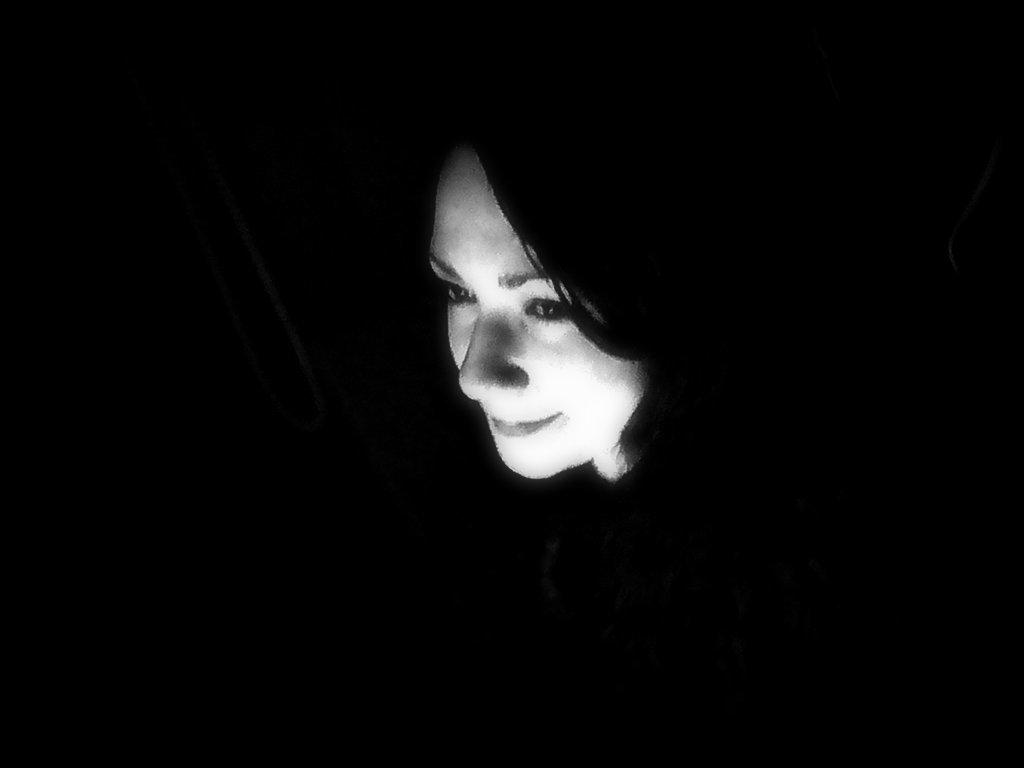What is the main subject of the image? There is a person's face in the image. What color is the background of the image? The background of the image is black. What direction is the boot facing in the image? There is no boot present in the image, so it is not possible to determine the direction it might be facing. 